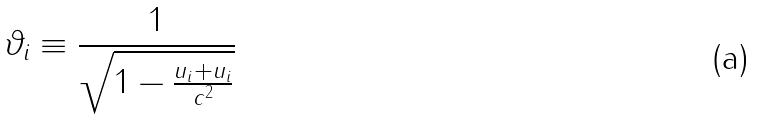Convert formula to latex. <formula><loc_0><loc_0><loc_500><loc_500>\vartheta _ { i } \equiv \frac { 1 } { \sqrt { 1 - \frac { u _ { i } + u _ { i } } { c ^ { 2 } } } }</formula> 